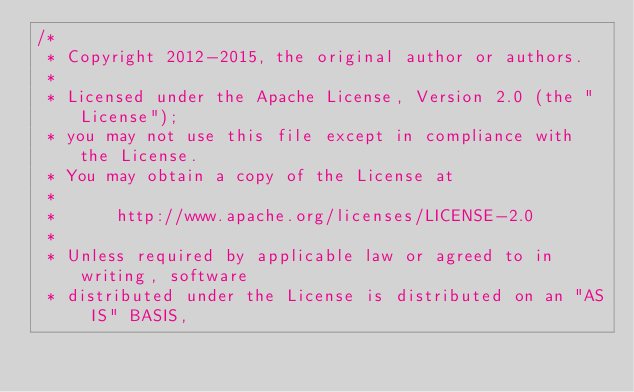<code> <loc_0><loc_0><loc_500><loc_500><_Java_>/*
 * Copyright 2012-2015, the original author or authors.
 *
 * Licensed under the Apache License, Version 2.0 (the "License");
 * you may not use this file except in compliance with the License.
 * You may obtain a copy of the License at
 *
 *      http://www.apache.org/licenses/LICENSE-2.0
 *
 * Unless required by applicable law or agreed to in writing, software
 * distributed under the License is distributed on an "AS IS" BASIS,</code> 